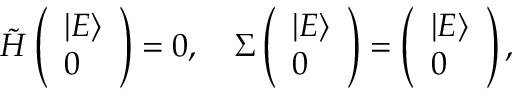Convert formula to latex. <formula><loc_0><loc_0><loc_500><loc_500>\begin{array} { r } { \tilde { H } \left ( \begin{array} { l } { | E \rangle } \\ { 0 } \end{array} \right ) = 0 , \quad \Sigma \left ( \begin{array} { l } { | E \rangle } \\ { 0 } \end{array} \right ) = \left ( \begin{array} { l } { | E \rangle } \\ { 0 } \end{array} \right ) , } \end{array}</formula> 